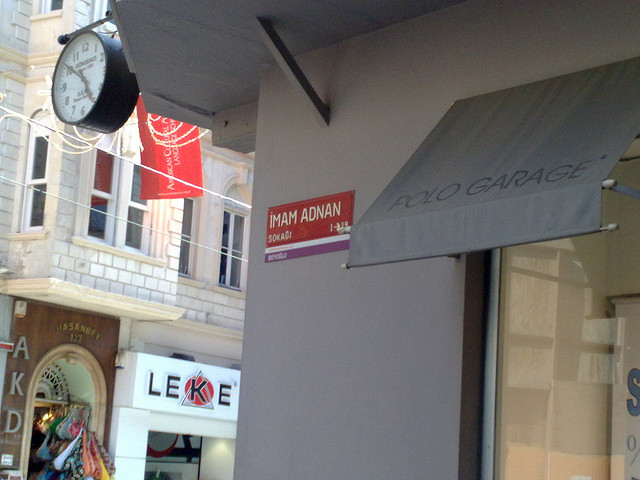<image>What flag is on the store's sign? It is unknown what flag is on the store's sign. What flag is on the store's sign? I am not sure what flag is on the store's sign. There are different possibilities such as 'red', 'store flag', 'business sign', 'advertisement', 'american' or 'polo garage'. 